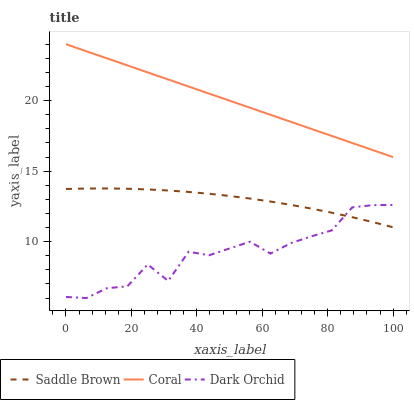Does Dark Orchid have the minimum area under the curve?
Answer yes or no. Yes. Does Coral have the maximum area under the curve?
Answer yes or no. Yes. Does Saddle Brown have the minimum area under the curve?
Answer yes or no. No. Does Saddle Brown have the maximum area under the curve?
Answer yes or no. No. Is Coral the smoothest?
Answer yes or no. Yes. Is Dark Orchid the roughest?
Answer yes or no. Yes. Is Saddle Brown the smoothest?
Answer yes or no. No. Is Saddle Brown the roughest?
Answer yes or no. No. Does Dark Orchid have the lowest value?
Answer yes or no. Yes. Does Saddle Brown have the lowest value?
Answer yes or no. No. Does Coral have the highest value?
Answer yes or no. Yes. Does Saddle Brown have the highest value?
Answer yes or no. No. Is Saddle Brown less than Coral?
Answer yes or no. Yes. Is Coral greater than Dark Orchid?
Answer yes or no. Yes. Does Saddle Brown intersect Dark Orchid?
Answer yes or no. Yes. Is Saddle Brown less than Dark Orchid?
Answer yes or no. No. Is Saddle Brown greater than Dark Orchid?
Answer yes or no. No. Does Saddle Brown intersect Coral?
Answer yes or no. No. 